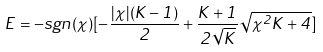<formula> <loc_0><loc_0><loc_500><loc_500>E = - s g n ( \chi ) [ - \frac { | \chi | ( K - 1 ) } { 2 } + \frac { K + 1 } { 2 \sqrt { K } } \sqrt { \chi ^ { 2 } K + 4 } ]</formula> 